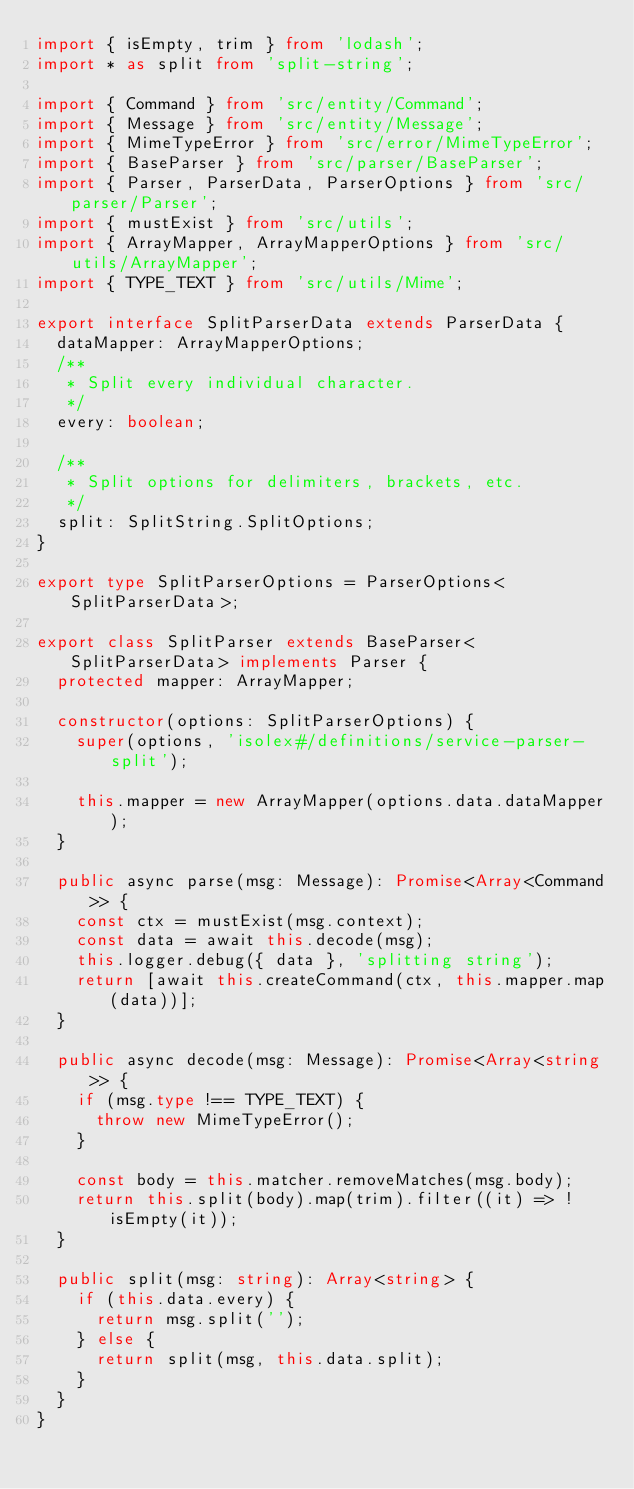<code> <loc_0><loc_0><loc_500><loc_500><_TypeScript_>import { isEmpty, trim } from 'lodash';
import * as split from 'split-string';

import { Command } from 'src/entity/Command';
import { Message } from 'src/entity/Message';
import { MimeTypeError } from 'src/error/MimeTypeError';
import { BaseParser } from 'src/parser/BaseParser';
import { Parser, ParserData, ParserOptions } from 'src/parser/Parser';
import { mustExist } from 'src/utils';
import { ArrayMapper, ArrayMapperOptions } from 'src/utils/ArrayMapper';
import { TYPE_TEXT } from 'src/utils/Mime';

export interface SplitParserData extends ParserData {
  dataMapper: ArrayMapperOptions;
  /**
   * Split every individual character.
   */
  every: boolean;

  /**
   * Split options for delimiters, brackets, etc.
   */
  split: SplitString.SplitOptions;
}

export type SplitParserOptions = ParserOptions<SplitParserData>;

export class SplitParser extends BaseParser<SplitParserData> implements Parser {
  protected mapper: ArrayMapper;

  constructor(options: SplitParserOptions) {
    super(options, 'isolex#/definitions/service-parser-split');

    this.mapper = new ArrayMapper(options.data.dataMapper);
  }

  public async parse(msg: Message): Promise<Array<Command>> {
    const ctx = mustExist(msg.context);
    const data = await this.decode(msg);
    this.logger.debug({ data }, 'splitting string');
    return [await this.createCommand(ctx, this.mapper.map(data))];
  }

  public async decode(msg: Message): Promise<Array<string>> {
    if (msg.type !== TYPE_TEXT) {
      throw new MimeTypeError();
    }

    const body = this.matcher.removeMatches(msg.body);
    return this.split(body).map(trim).filter((it) => !isEmpty(it));
  }

  public split(msg: string): Array<string> {
    if (this.data.every) {
      return msg.split('');
    } else {
      return split(msg, this.data.split);
    }
  }
}
</code> 